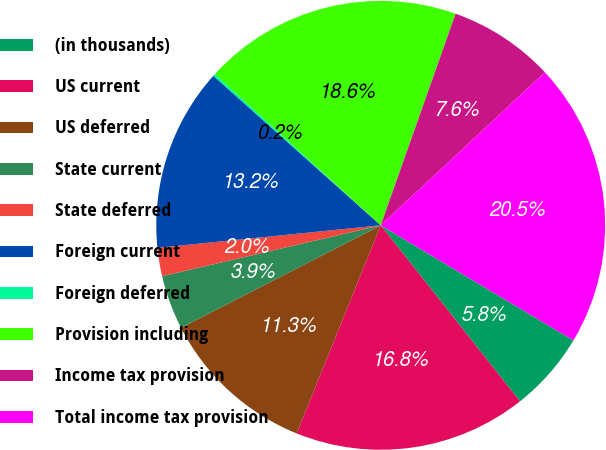Convert chart to OTSL. <chart><loc_0><loc_0><loc_500><loc_500><pie_chart><fcel>(in thousands)<fcel>US current<fcel>US deferred<fcel>State current<fcel>State deferred<fcel>Foreign current<fcel>Foreign deferred<fcel>Provision including<fcel>Income tax provision<fcel>Total income tax provision<nl><fcel>5.78%<fcel>16.77%<fcel>11.34%<fcel>3.91%<fcel>2.04%<fcel>13.21%<fcel>0.17%<fcel>18.64%<fcel>7.65%<fcel>20.51%<nl></chart> 